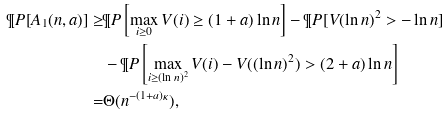<formula> <loc_0><loc_0><loc_500><loc_500>\P P [ A _ { 1 } ( n , a ) ] \geq & \P P \left [ \max _ { i \geq 0 } V ( i ) \geq ( 1 + a ) \ln n \right ] - \P P [ V ( \ln n ) ^ { 2 } > - \ln n ] \\ & - \P P \left [ \max _ { i \geq ( \ln n ) ^ { 2 } } V ( i ) - V ( ( \ln n ) ^ { 2 } ) > ( 2 + a ) \ln n \right ] \\ = & \Theta ( n ^ { - ( 1 + a ) \kappa } ) ,</formula> 